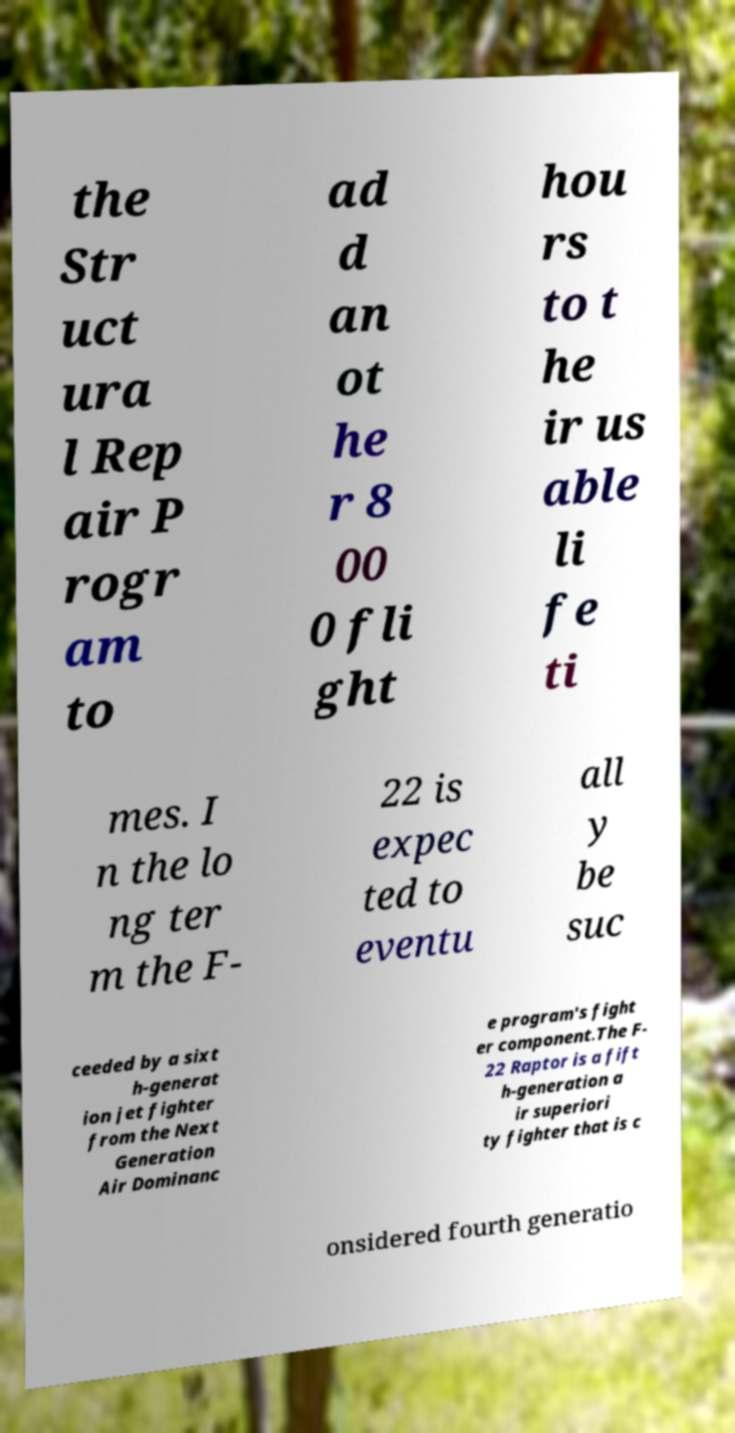There's text embedded in this image that I need extracted. Can you transcribe it verbatim? the Str uct ura l Rep air P rogr am to ad d an ot he r 8 00 0 fli ght hou rs to t he ir us able li fe ti mes. I n the lo ng ter m the F- 22 is expec ted to eventu all y be suc ceeded by a sixt h-generat ion jet fighter from the Next Generation Air Dominanc e program's fight er component.The F- 22 Raptor is a fift h-generation a ir superiori ty fighter that is c onsidered fourth generatio 